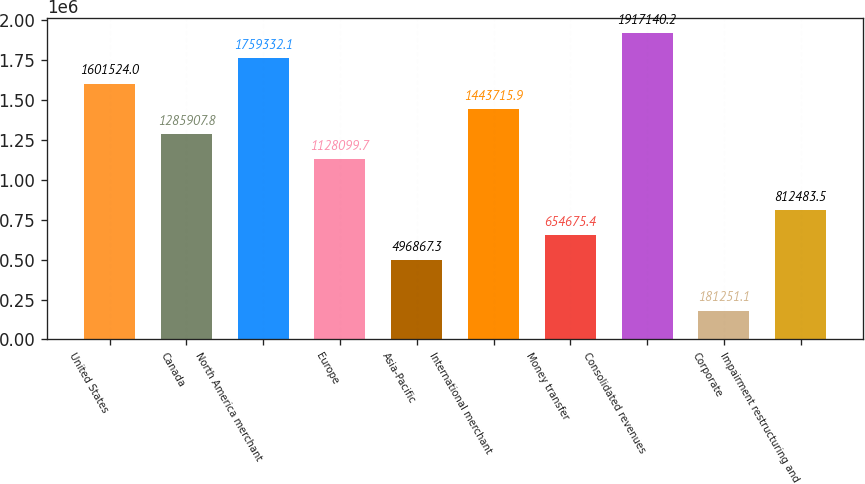<chart> <loc_0><loc_0><loc_500><loc_500><bar_chart><fcel>United States<fcel>Canada<fcel>North America merchant<fcel>Europe<fcel>Asia-Pacific<fcel>International merchant<fcel>Money transfer<fcel>Consolidated revenues<fcel>Corporate<fcel>Impairment restructuring and<nl><fcel>1.60152e+06<fcel>1.28591e+06<fcel>1.75933e+06<fcel>1.1281e+06<fcel>496867<fcel>1.44372e+06<fcel>654675<fcel>1.91714e+06<fcel>181251<fcel>812484<nl></chart> 